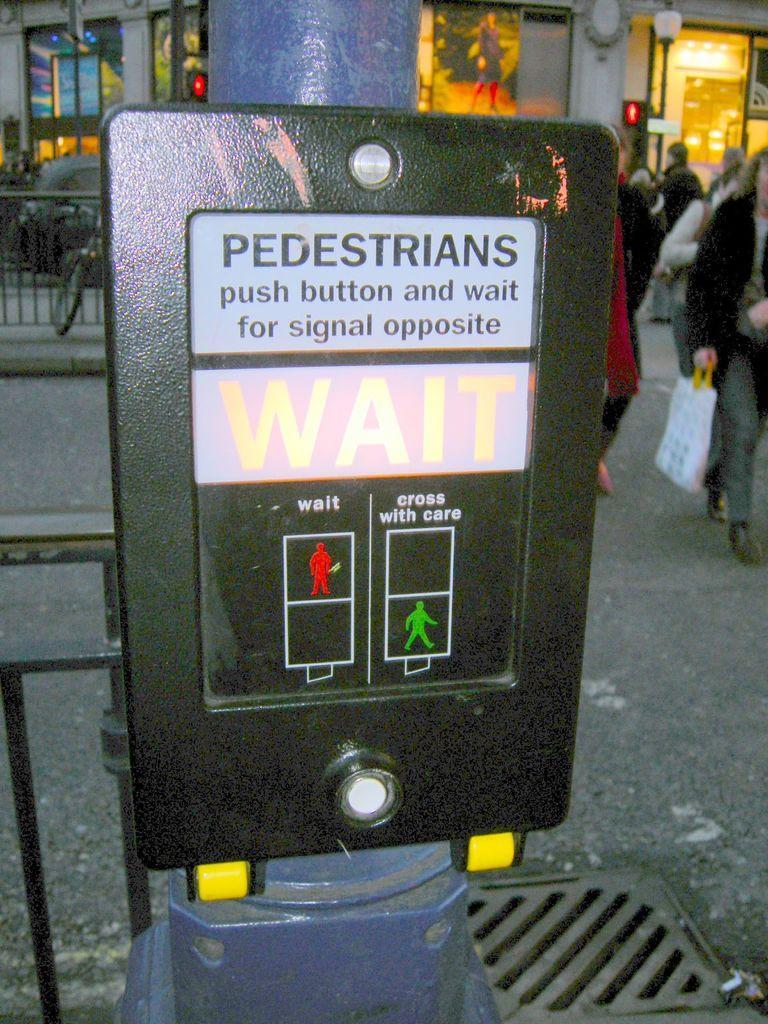Can you describe this image briefly? In this image we can see a sign board and there are people. On the left there is a bicycle and a car. There is a railing. In the background we can see a building. 